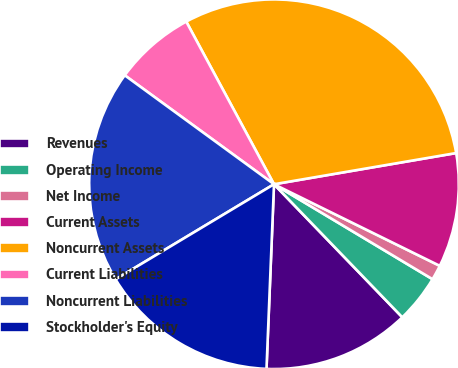Convert chart. <chart><loc_0><loc_0><loc_500><loc_500><pie_chart><fcel>Revenues<fcel>Operating Income<fcel>Net Income<fcel>Current Assets<fcel>Noncurrent Assets<fcel>Current Liabilities<fcel>Noncurrent Liabilities<fcel>Stockholder's Equity<nl><fcel>12.86%<fcel>4.2%<fcel>1.31%<fcel>9.98%<fcel>30.18%<fcel>7.09%<fcel>18.64%<fcel>15.75%<nl></chart> 